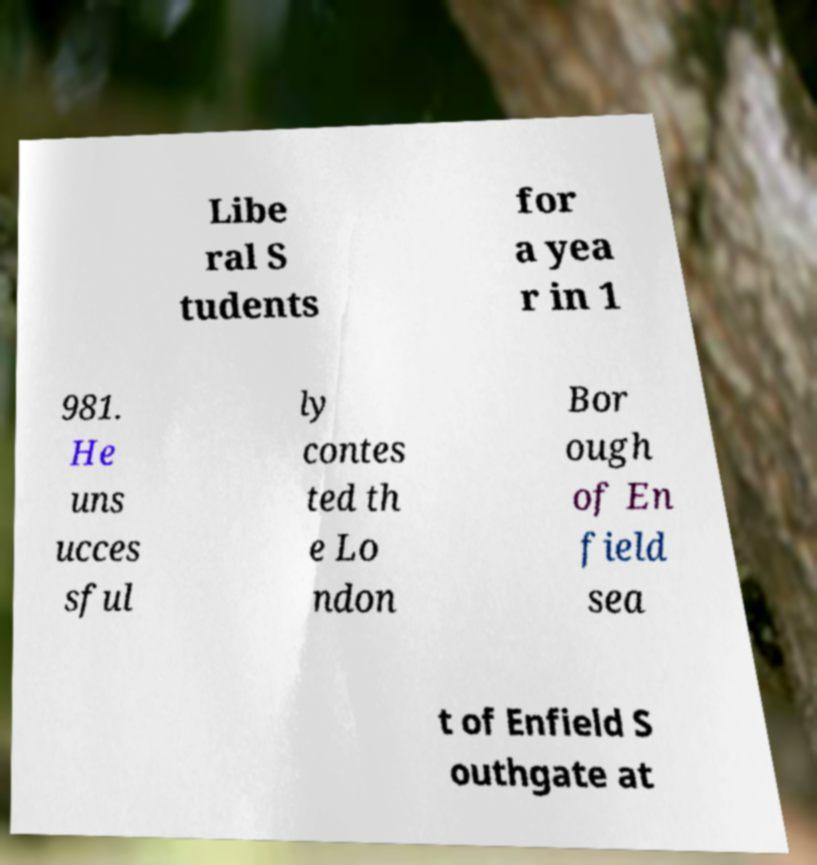Could you assist in decoding the text presented in this image and type it out clearly? Libe ral S tudents for a yea r in 1 981. He uns ucces sful ly contes ted th e Lo ndon Bor ough of En field sea t of Enfield S outhgate at 